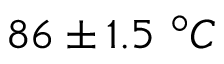Convert formula to latex. <formula><loc_0><loc_0><loc_500><loc_500>8 6 \pm 1 . 5 ^ { \circ } C</formula> 